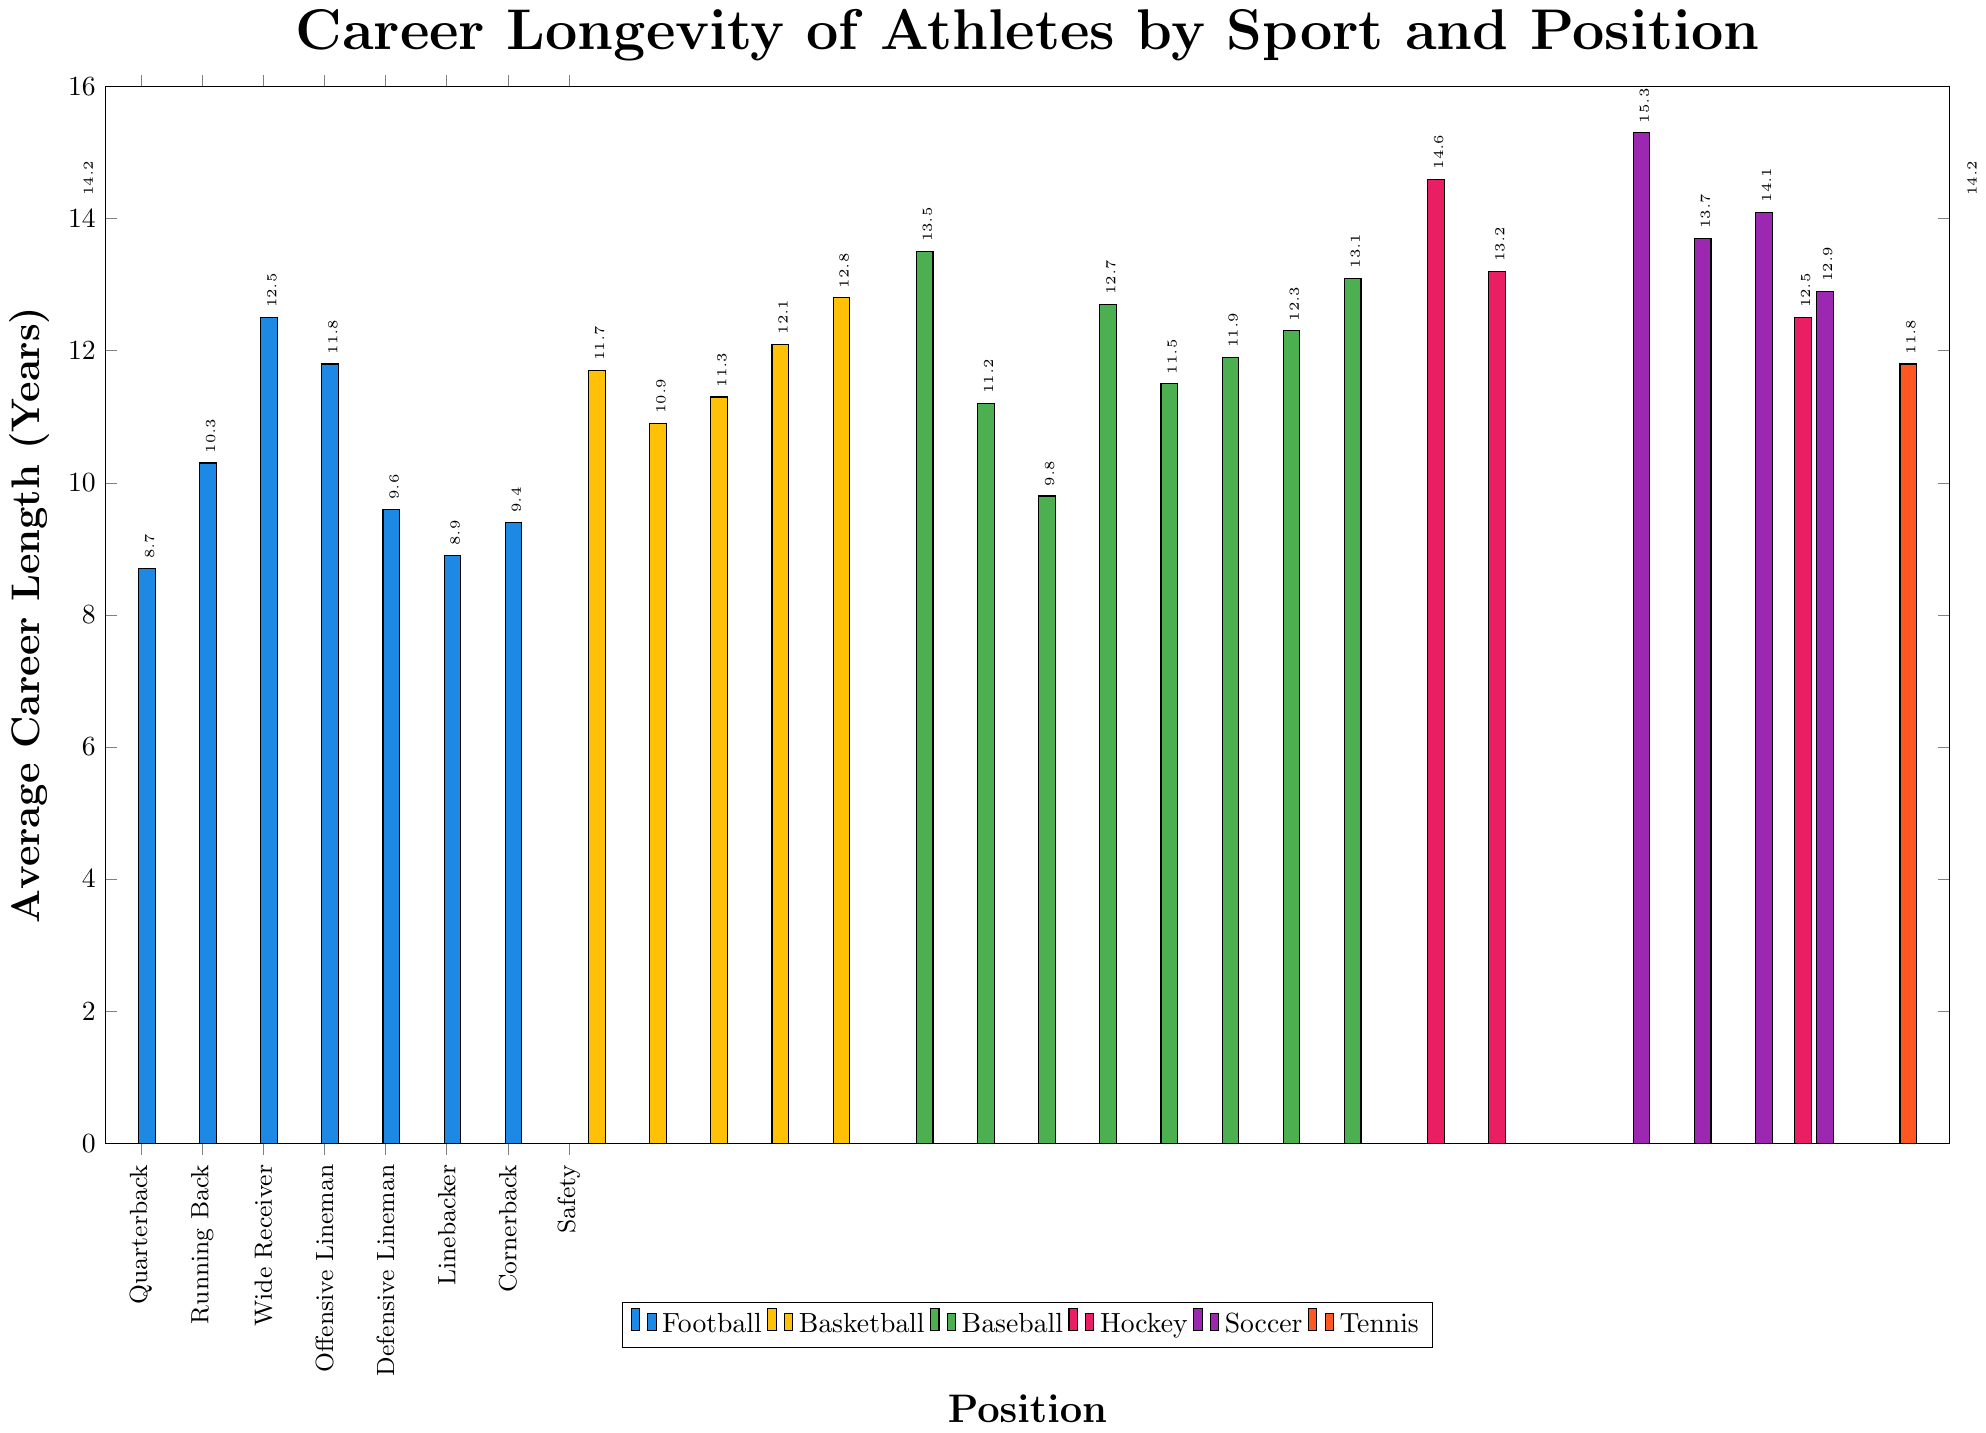Which position in soccer has the longest average career length? Look at the bars corresponding to soccer positions and identify the highest one. The Goalkeeper bar is the tallest.
Answer: Goalkeeper Which sport has the position with the shortest average career length, and what is that position's length? Find the shortest bar among all positions across each sport. The Running Back in Football has the shortest career length at 8.7 years.
Answer: Football, Running Back, 8.7 years Compare the average career length of a Tennis Singles Player to a Tennis Doubles Specialist. Which one is longer, and by how many years? Locate the bars for the Tennis Singles Player and Tennis Doubles Specialist. The Doubles Specialist has a longer career length (14.2 years) compared to the Singles Player (11.8 years). Calculate the difference: 14.2 - 11.8 = 2.4 years.
Answer: Doubles Specialist, by 2.4 years What is the average career length of a football Quarterback compared to a basketball Center? Locate the bars for the football Quarterback and basketball Center. The football Quarterback has a career length of 14.2 years while the basketball Center has 12.8 years.
Answer: Quarterback, 14.2 years and Center, 12.8 years Which position has the longest average career length in Baseball, and how does it compare to the longest average career length in Hockey? Identify the highest bar in Baseball and the highest bar in Hockey. In Baseball, the Starting Pitcher has the longest career length of 13.5 years, whereas, in Hockey, the Goalie has the longest career length of 14.6 years. Compare the two values: 14.6 - 13.5 = 1.1 years.
Answer: Hockey Goalie, by 1.1 years How does the average career length of a Defensive Lineman in Football compare to that of a Defender in Soccer? Look at the respective bars for Defensive Lineman in Football and Defender in Soccer. The Defensive Lineman has an average career length of 11.8 years, and the Defender has 13.7 years.
Answer: Defender in Soccer is longer, by 1.9 years Calculate the average career length for all basketball positions shown. Sum the average career lengths of all basketball positions: (11.7 + 10.9 + 11.3 + 12.1 + 12.8) = 58.8. There are 5 positions, so divide the sum by 5: 58.8 / 5 = 11.76 years.
Answer: 11.76 years Which sport has the largest variation between the longest and shortest average career lengths? Calculate the range for each sport and compare. Football: 14.2 - 8.7 = 5.5 years, Basketball: 12.8 - 10.9 = 1.9 years, Baseball: 13.5 - 9.8 = 3.7 years, Hockey: 14.6 - 12.5 = 2.1 years, Soccer: 15.3 - 12.9 = 2.4 years, Tennis: 14.2 - 11.8 = 2.4 years. Football has the largest range of 5.5 years.
Answer: Football Find the combined average career length of all positions in Hockey. Sum the career lengths of all hockey positions: (14.6 + 13.2 + 12.5) = 40.3. There are 3 positions, so divide the sum by 3: 40.3 / 3 ≈ 13.43 years.
Answer: 13.43 years 